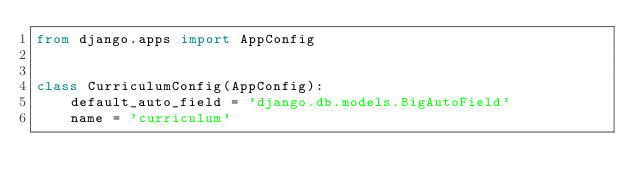<code> <loc_0><loc_0><loc_500><loc_500><_Python_>from django.apps import AppConfig


class CurriculumConfig(AppConfig):
    default_auto_field = 'django.db.models.BigAutoField'
    name = 'curriculum'
</code> 